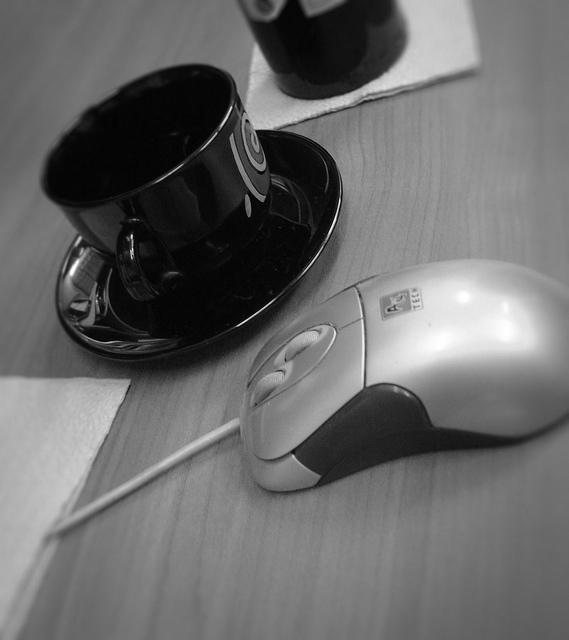Is this a cordless mouse?
Answer briefly. No. Is this photo black & white?
Be succinct. Yes. What kind of mouse is this?
Short answer required. Computer. 